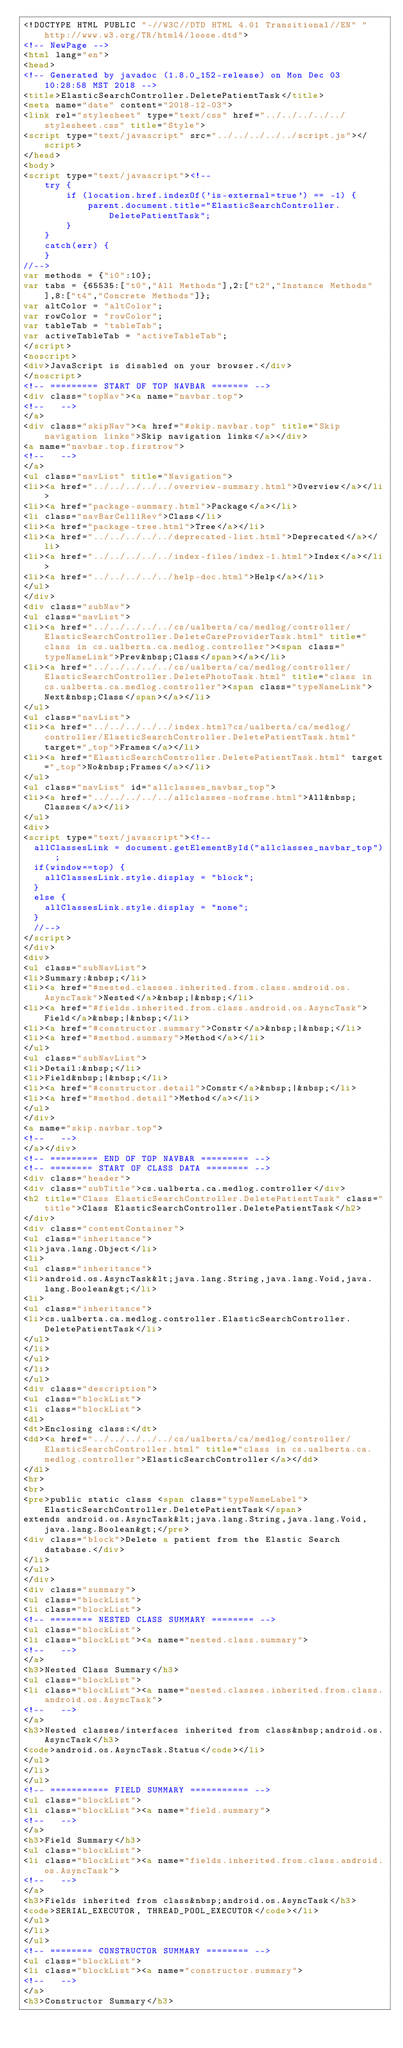<code> <loc_0><loc_0><loc_500><loc_500><_HTML_><!DOCTYPE HTML PUBLIC "-//W3C//DTD HTML 4.01 Transitional//EN" "http://www.w3.org/TR/html4/loose.dtd">
<!-- NewPage -->
<html lang="en">
<head>
<!-- Generated by javadoc (1.8.0_152-release) on Mon Dec 03 10:28:58 MST 2018 -->
<title>ElasticSearchController.DeletePatientTask</title>
<meta name="date" content="2018-12-03">
<link rel="stylesheet" type="text/css" href="../../../../../stylesheet.css" title="Style">
<script type="text/javascript" src="../../../../../script.js"></script>
</head>
<body>
<script type="text/javascript"><!--
    try {
        if (location.href.indexOf('is-external=true') == -1) {
            parent.document.title="ElasticSearchController.DeletePatientTask";
        }
    }
    catch(err) {
    }
//-->
var methods = {"i0":10};
var tabs = {65535:["t0","All Methods"],2:["t2","Instance Methods"],8:["t4","Concrete Methods"]};
var altColor = "altColor";
var rowColor = "rowColor";
var tableTab = "tableTab";
var activeTableTab = "activeTableTab";
</script>
<noscript>
<div>JavaScript is disabled on your browser.</div>
</noscript>
<!-- ========= START OF TOP NAVBAR ======= -->
<div class="topNav"><a name="navbar.top">
<!--   -->
</a>
<div class="skipNav"><a href="#skip.navbar.top" title="Skip navigation links">Skip navigation links</a></div>
<a name="navbar.top.firstrow">
<!--   -->
</a>
<ul class="navList" title="Navigation">
<li><a href="../../../../../overview-summary.html">Overview</a></li>
<li><a href="package-summary.html">Package</a></li>
<li class="navBarCell1Rev">Class</li>
<li><a href="package-tree.html">Tree</a></li>
<li><a href="../../../../../deprecated-list.html">Deprecated</a></li>
<li><a href="../../../../../index-files/index-1.html">Index</a></li>
<li><a href="../../../../../help-doc.html">Help</a></li>
</ul>
</div>
<div class="subNav">
<ul class="navList">
<li><a href="../../../../../cs/ualberta/ca/medlog/controller/ElasticSearchController.DeleteCareProviderTask.html" title="class in cs.ualberta.ca.medlog.controller"><span class="typeNameLink">Prev&nbsp;Class</span></a></li>
<li><a href="../../../../../cs/ualberta/ca/medlog/controller/ElasticSearchController.DeletePhotoTask.html" title="class in cs.ualberta.ca.medlog.controller"><span class="typeNameLink">Next&nbsp;Class</span></a></li>
</ul>
<ul class="navList">
<li><a href="../../../../../index.html?cs/ualberta/ca/medlog/controller/ElasticSearchController.DeletePatientTask.html" target="_top">Frames</a></li>
<li><a href="ElasticSearchController.DeletePatientTask.html" target="_top">No&nbsp;Frames</a></li>
</ul>
<ul class="navList" id="allclasses_navbar_top">
<li><a href="../../../../../allclasses-noframe.html">All&nbsp;Classes</a></li>
</ul>
<div>
<script type="text/javascript"><!--
  allClassesLink = document.getElementById("allclasses_navbar_top");
  if(window==top) {
    allClassesLink.style.display = "block";
  }
  else {
    allClassesLink.style.display = "none";
  }
  //-->
</script>
</div>
<div>
<ul class="subNavList">
<li>Summary:&nbsp;</li>
<li><a href="#nested.classes.inherited.from.class.android.os.AsyncTask">Nested</a>&nbsp;|&nbsp;</li>
<li><a href="#fields.inherited.from.class.android.os.AsyncTask">Field</a>&nbsp;|&nbsp;</li>
<li><a href="#constructor.summary">Constr</a>&nbsp;|&nbsp;</li>
<li><a href="#method.summary">Method</a></li>
</ul>
<ul class="subNavList">
<li>Detail:&nbsp;</li>
<li>Field&nbsp;|&nbsp;</li>
<li><a href="#constructor.detail">Constr</a>&nbsp;|&nbsp;</li>
<li><a href="#method.detail">Method</a></li>
</ul>
</div>
<a name="skip.navbar.top">
<!--   -->
</a></div>
<!-- ========= END OF TOP NAVBAR ========= -->
<!-- ======== START OF CLASS DATA ======== -->
<div class="header">
<div class="subTitle">cs.ualberta.ca.medlog.controller</div>
<h2 title="Class ElasticSearchController.DeletePatientTask" class="title">Class ElasticSearchController.DeletePatientTask</h2>
</div>
<div class="contentContainer">
<ul class="inheritance">
<li>java.lang.Object</li>
<li>
<ul class="inheritance">
<li>android.os.AsyncTask&lt;java.lang.String,java.lang.Void,java.lang.Boolean&gt;</li>
<li>
<ul class="inheritance">
<li>cs.ualberta.ca.medlog.controller.ElasticSearchController.DeletePatientTask</li>
</ul>
</li>
</ul>
</li>
</ul>
<div class="description">
<ul class="blockList">
<li class="blockList">
<dl>
<dt>Enclosing class:</dt>
<dd><a href="../../../../../cs/ualberta/ca/medlog/controller/ElasticSearchController.html" title="class in cs.ualberta.ca.medlog.controller">ElasticSearchController</a></dd>
</dl>
<hr>
<br>
<pre>public static class <span class="typeNameLabel">ElasticSearchController.DeletePatientTask</span>
extends android.os.AsyncTask&lt;java.lang.String,java.lang.Void,java.lang.Boolean&gt;</pre>
<div class="block">Delete a patient from the Elastic Search database.</div>
</li>
</ul>
</div>
<div class="summary">
<ul class="blockList">
<li class="blockList">
<!-- ======== NESTED CLASS SUMMARY ======== -->
<ul class="blockList">
<li class="blockList"><a name="nested.class.summary">
<!--   -->
</a>
<h3>Nested Class Summary</h3>
<ul class="blockList">
<li class="blockList"><a name="nested.classes.inherited.from.class.android.os.AsyncTask">
<!--   -->
</a>
<h3>Nested classes/interfaces inherited from class&nbsp;android.os.AsyncTask</h3>
<code>android.os.AsyncTask.Status</code></li>
</ul>
</li>
</ul>
<!-- =========== FIELD SUMMARY =========== -->
<ul class="blockList">
<li class="blockList"><a name="field.summary">
<!--   -->
</a>
<h3>Field Summary</h3>
<ul class="blockList">
<li class="blockList"><a name="fields.inherited.from.class.android.os.AsyncTask">
<!--   -->
</a>
<h3>Fields inherited from class&nbsp;android.os.AsyncTask</h3>
<code>SERIAL_EXECUTOR, THREAD_POOL_EXECUTOR</code></li>
</ul>
</li>
</ul>
<!-- ======== CONSTRUCTOR SUMMARY ======== -->
<ul class="blockList">
<li class="blockList"><a name="constructor.summary">
<!--   -->
</a>
<h3>Constructor Summary</h3></code> 